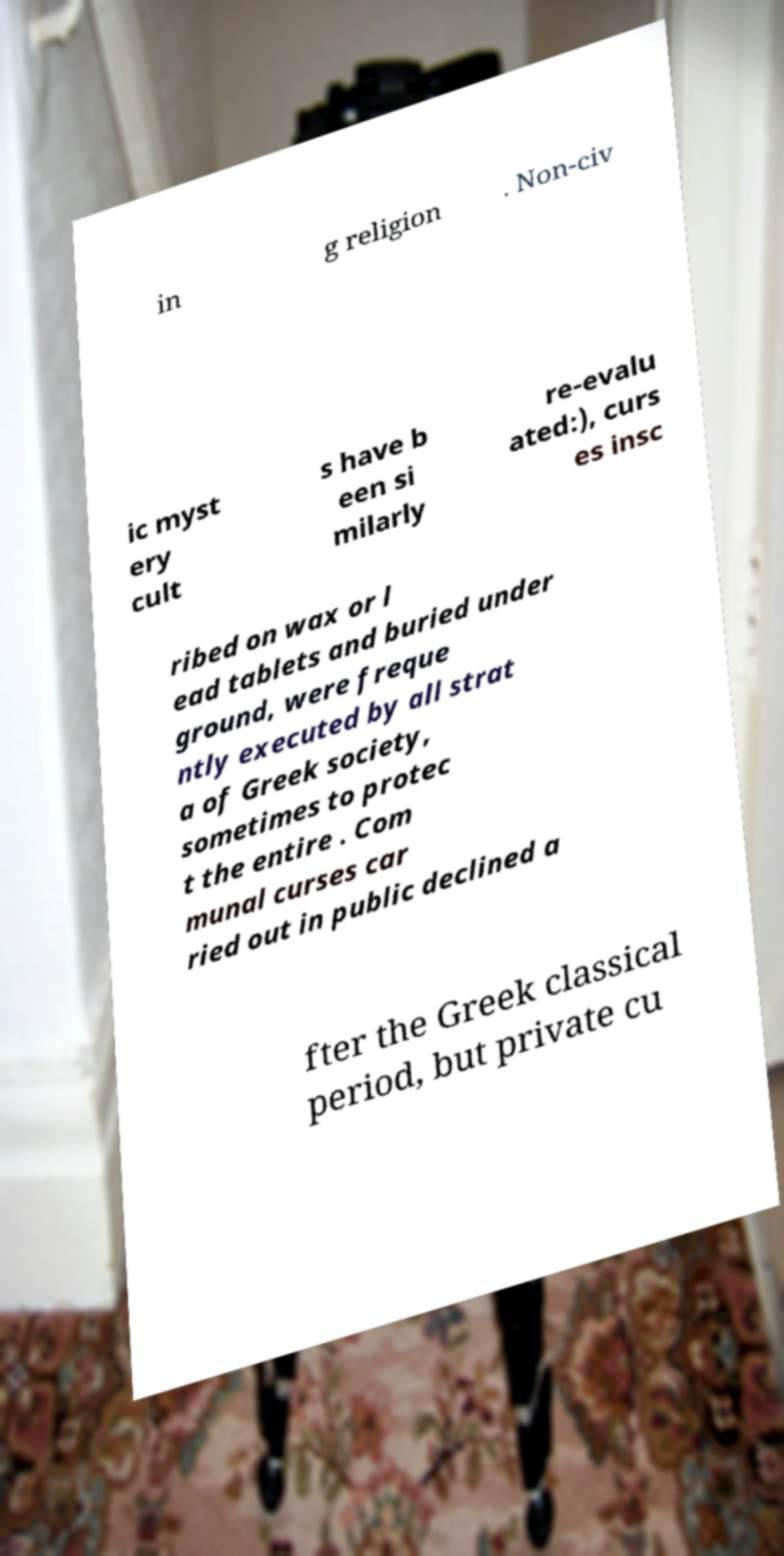I need the written content from this picture converted into text. Can you do that? in g religion . Non-civ ic myst ery cult s have b een si milarly re-evalu ated:), curs es insc ribed on wax or l ead tablets and buried under ground, were freque ntly executed by all strat a of Greek society, sometimes to protec t the entire . Com munal curses car ried out in public declined a fter the Greek classical period, but private cu 